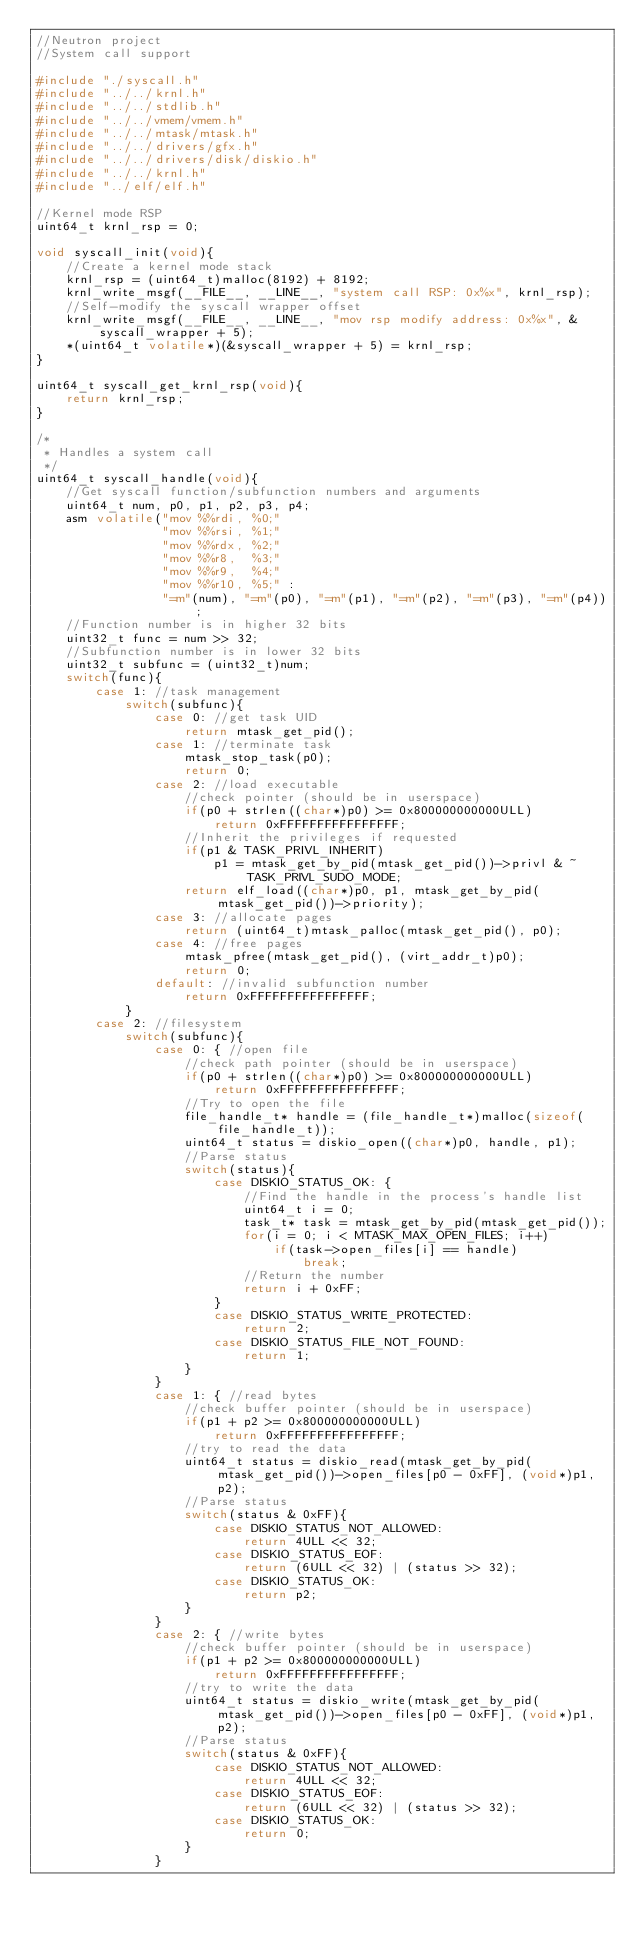<code> <loc_0><loc_0><loc_500><loc_500><_C_>//Neutron project
//System call support

#include "./syscall.h"
#include "../../krnl.h"
#include "../../stdlib.h"
#include "../../vmem/vmem.h"
#include "../../mtask/mtask.h"
#include "../../drivers/gfx.h"
#include "../../drivers/disk/diskio.h"
#include "../../krnl.h"
#include "../elf/elf.h"

//Kernel mode RSP
uint64_t krnl_rsp = 0;

void syscall_init(void){
    //Create a kernel mode stack
    krnl_rsp = (uint64_t)malloc(8192) + 8192;
    krnl_write_msgf(__FILE__, __LINE__, "system call RSP: 0x%x", krnl_rsp);
    //Self-modify the syscall wrapper offset
    krnl_write_msgf(__FILE__, __LINE__, "mov rsp modify address: 0x%x", &syscall_wrapper + 5);
    *(uint64_t volatile*)(&syscall_wrapper + 5) = krnl_rsp;
}

uint64_t syscall_get_krnl_rsp(void){
    return krnl_rsp;
}

/*
 * Handles a system call
 */
uint64_t syscall_handle(void){
    //Get syscall function/subfunction numbers and arguments
    uint64_t num, p0, p1, p2, p3, p4;
    asm volatile("mov %%rdi, %0;"
                 "mov %%rsi, %1;"
                 "mov %%rdx, %2;"
                 "mov %%r8,  %3;"
                 "mov %%r9,  %4;"
                 "mov %%r10, %5;" :
                 "=m"(num), "=m"(p0), "=m"(p1), "=m"(p2), "=m"(p3), "=m"(p4));
    //Function number is in higher 32 bits
    uint32_t func = num >> 32;
    //Subfunction number is in lower 32 bits
    uint32_t subfunc = (uint32_t)num;
    switch(func){
        case 1: //task management
            switch(subfunc){
                case 0: //get task UID
                    return mtask_get_pid();
                case 1: //terminate task
                    mtask_stop_task(p0);
                    return 0;
                case 2: //load executable
                    //check pointer (should be in userspace)
                    if(p0 + strlen((char*)p0) >= 0x800000000000ULL)
                        return 0xFFFFFFFFFFFFFFFF;
                    //Inherit the privileges if requested
                    if(p1 & TASK_PRIVL_INHERIT)
                        p1 = mtask_get_by_pid(mtask_get_pid())->privl & ~TASK_PRIVL_SUDO_MODE;
                    return elf_load((char*)p0, p1, mtask_get_by_pid(mtask_get_pid())->priority);
                case 3: //allocate pages
                    return (uint64_t)mtask_palloc(mtask_get_pid(), p0);
                case 4: //free pages
                    mtask_pfree(mtask_get_pid(), (virt_addr_t)p0);
                    return 0;
                default: //invalid subfunction number
                    return 0xFFFFFFFFFFFFFFFF;
            }
        case 2: //filesystem
            switch(subfunc){
                case 0: { //open file
                    //check path pointer (should be in userspace)
                    if(p0 + strlen((char*)p0) >= 0x800000000000ULL)
                        return 0xFFFFFFFFFFFFFFFF;
                    //Try to open the file
                    file_handle_t* handle = (file_handle_t*)malloc(sizeof(file_handle_t));
                    uint64_t status = diskio_open((char*)p0, handle, p1);
                    //Parse status
                    switch(status){
                        case DISKIO_STATUS_OK: {
                            //Find the handle in the process's handle list
                            uint64_t i = 0;
                            task_t* task = mtask_get_by_pid(mtask_get_pid());
                            for(i = 0; i < MTASK_MAX_OPEN_FILES; i++)
                                if(task->open_files[i] == handle)
                                    break;
                            //Return the number
                            return i + 0xFF;
                        }
                        case DISKIO_STATUS_WRITE_PROTECTED:
                            return 2;
                        case DISKIO_STATUS_FILE_NOT_FOUND:
                            return 1;
                    }
                }
                case 1: { //read bytes
                    //check buffer pointer (should be in userspace)
                    if(p1 + p2 >= 0x800000000000ULL)
                        return 0xFFFFFFFFFFFFFFFF;
                    //try to read the data
                    uint64_t status = diskio_read(mtask_get_by_pid(mtask_get_pid())->open_files[p0 - 0xFF], (void*)p1, p2);
                    //Parse status
                    switch(status & 0xFF){
                        case DISKIO_STATUS_NOT_ALLOWED:
                            return 4ULL << 32;
                        case DISKIO_STATUS_EOF:
                            return (6ULL << 32) | (status >> 32);
                        case DISKIO_STATUS_OK:
                            return p2;
                    }
                }
                case 2: { //write bytes
                    //check buffer pointer (should be in userspace)
                    if(p1 + p2 >= 0x800000000000ULL)
                        return 0xFFFFFFFFFFFFFFFF;
                    //try to write the data
                    uint64_t status = diskio_write(mtask_get_by_pid(mtask_get_pid())->open_files[p0 - 0xFF], (void*)p1, p2);
                    //Parse status
                    switch(status & 0xFF){
                        case DISKIO_STATUS_NOT_ALLOWED:
                            return 4ULL << 32;
                        case DISKIO_STATUS_EOF:
                            return (6ULL << 32) | (status >> 32);
                        case DISKIO_STATUS_OK:
                            return 0;
                    }
                }</code> 